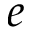<formula> <loc_0><loc_0><loc_500><loc_500>e</formula> 